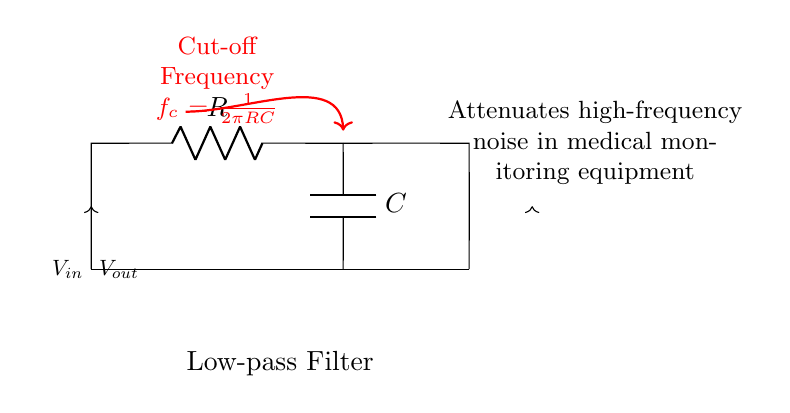What are the components of this filter circuit? The circuit diagram includes a resistor (R) and a capacitor (C). These components are integral parts of the low-pass filter configuration, as indicated in the diagram.
Answer: Resistor and capacitor What is the purpose of this circuit? The diagram states that the circuit attenuates high-frequency noise in medical monitoring equipment, indicating its function in filtering unwanted signal noise.
Answer: Noise reduction What is the cut-off frequency formula? The diagram provides the formula for the cut-off frequency as f_c = 1/(2πRC). This formula shows how the cut-off frequency depends on resistor and capacitor values.
Answer: f_c = 1/(2πRC) If the resistance is doubled, how does the cut-off frequency change? Doubling the resistance will result in halving the cut-off frequency, as seen in the formula f_c = 1/(2πRC), where an increase in R directly decreases f_c.
Answer: Halved What type of filter is shown in the circuit? The circuit is identified as a low-pass filter, indicated clearly in the label within the diagram. This classification is based on its functionality to allow low frequencies to pass while attenuating high frequencies.
Answer: Low-pass filter What happens to high-frequency signals in this circuit? The circuit is designed to attenuate high-frequency signals, which means these signals will be reduced in amplitude when passing through the circuit. This is crucial for reducing noise in outputs of medical monitoring devices.
Answer: Attenuated 